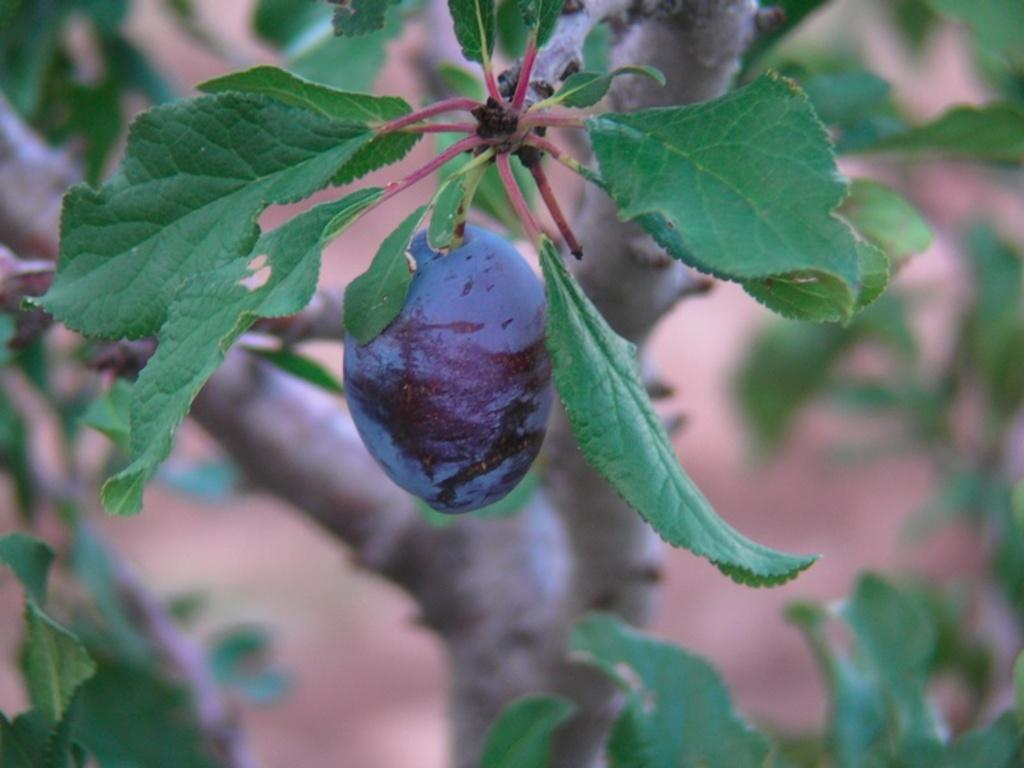What is present in the picture? There is a tree in the picture. Can you describe the tree further? There is a fruit on the tree. What type of company can be seen in the alley behind the tree? There is no company or alley present in the image; it only features a tree with fruit on it. 